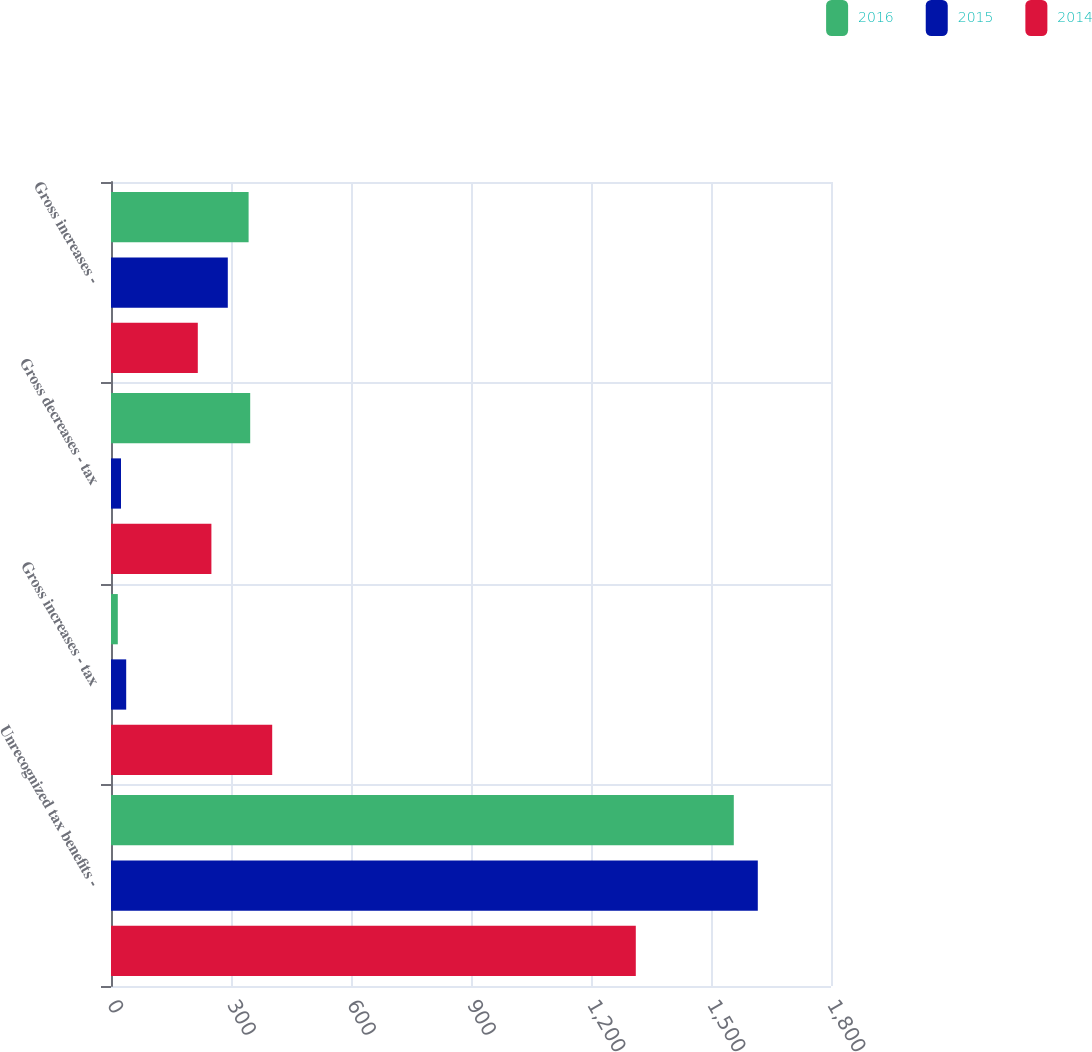Convert chart. <chart><loc_0><loc_0><loc_500><loc_500><stacked_bar_chart><ecel><fcel>Unrecognized tax benefits -<fcel>Gross increases - tax<fcel>Gross decreases - tax<fcel>Gross increases -<nl><fcel>2016<fcel>1557<fcel>17<fcel>348<fcel>344<nl><fcel>2015<fcel>1617<fcel>38<fcel>25<fcel>292<nl><fcel>2014<fcel>1312<fcel>403<fcel>251<fcel>217<nl></chart> 